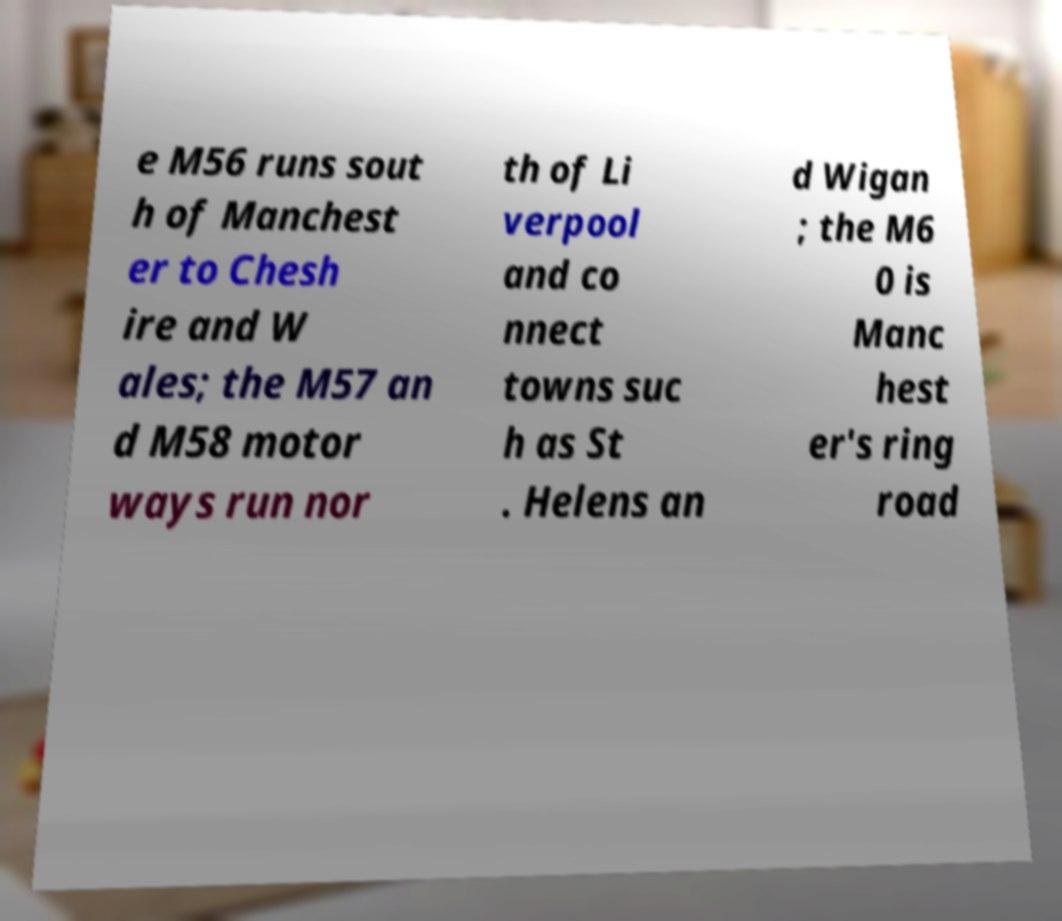What messages or text are displayed in this image? I need them in a readable, typed format. e M56 runs sout h of Manchest er to Chesh ire and W ales; the M57 an d M58 motor ways run nor th of Li verpool and co nnect towns suc h as St . Helens an d Wigan ; the M6 0 is Manc hest er's ring road 